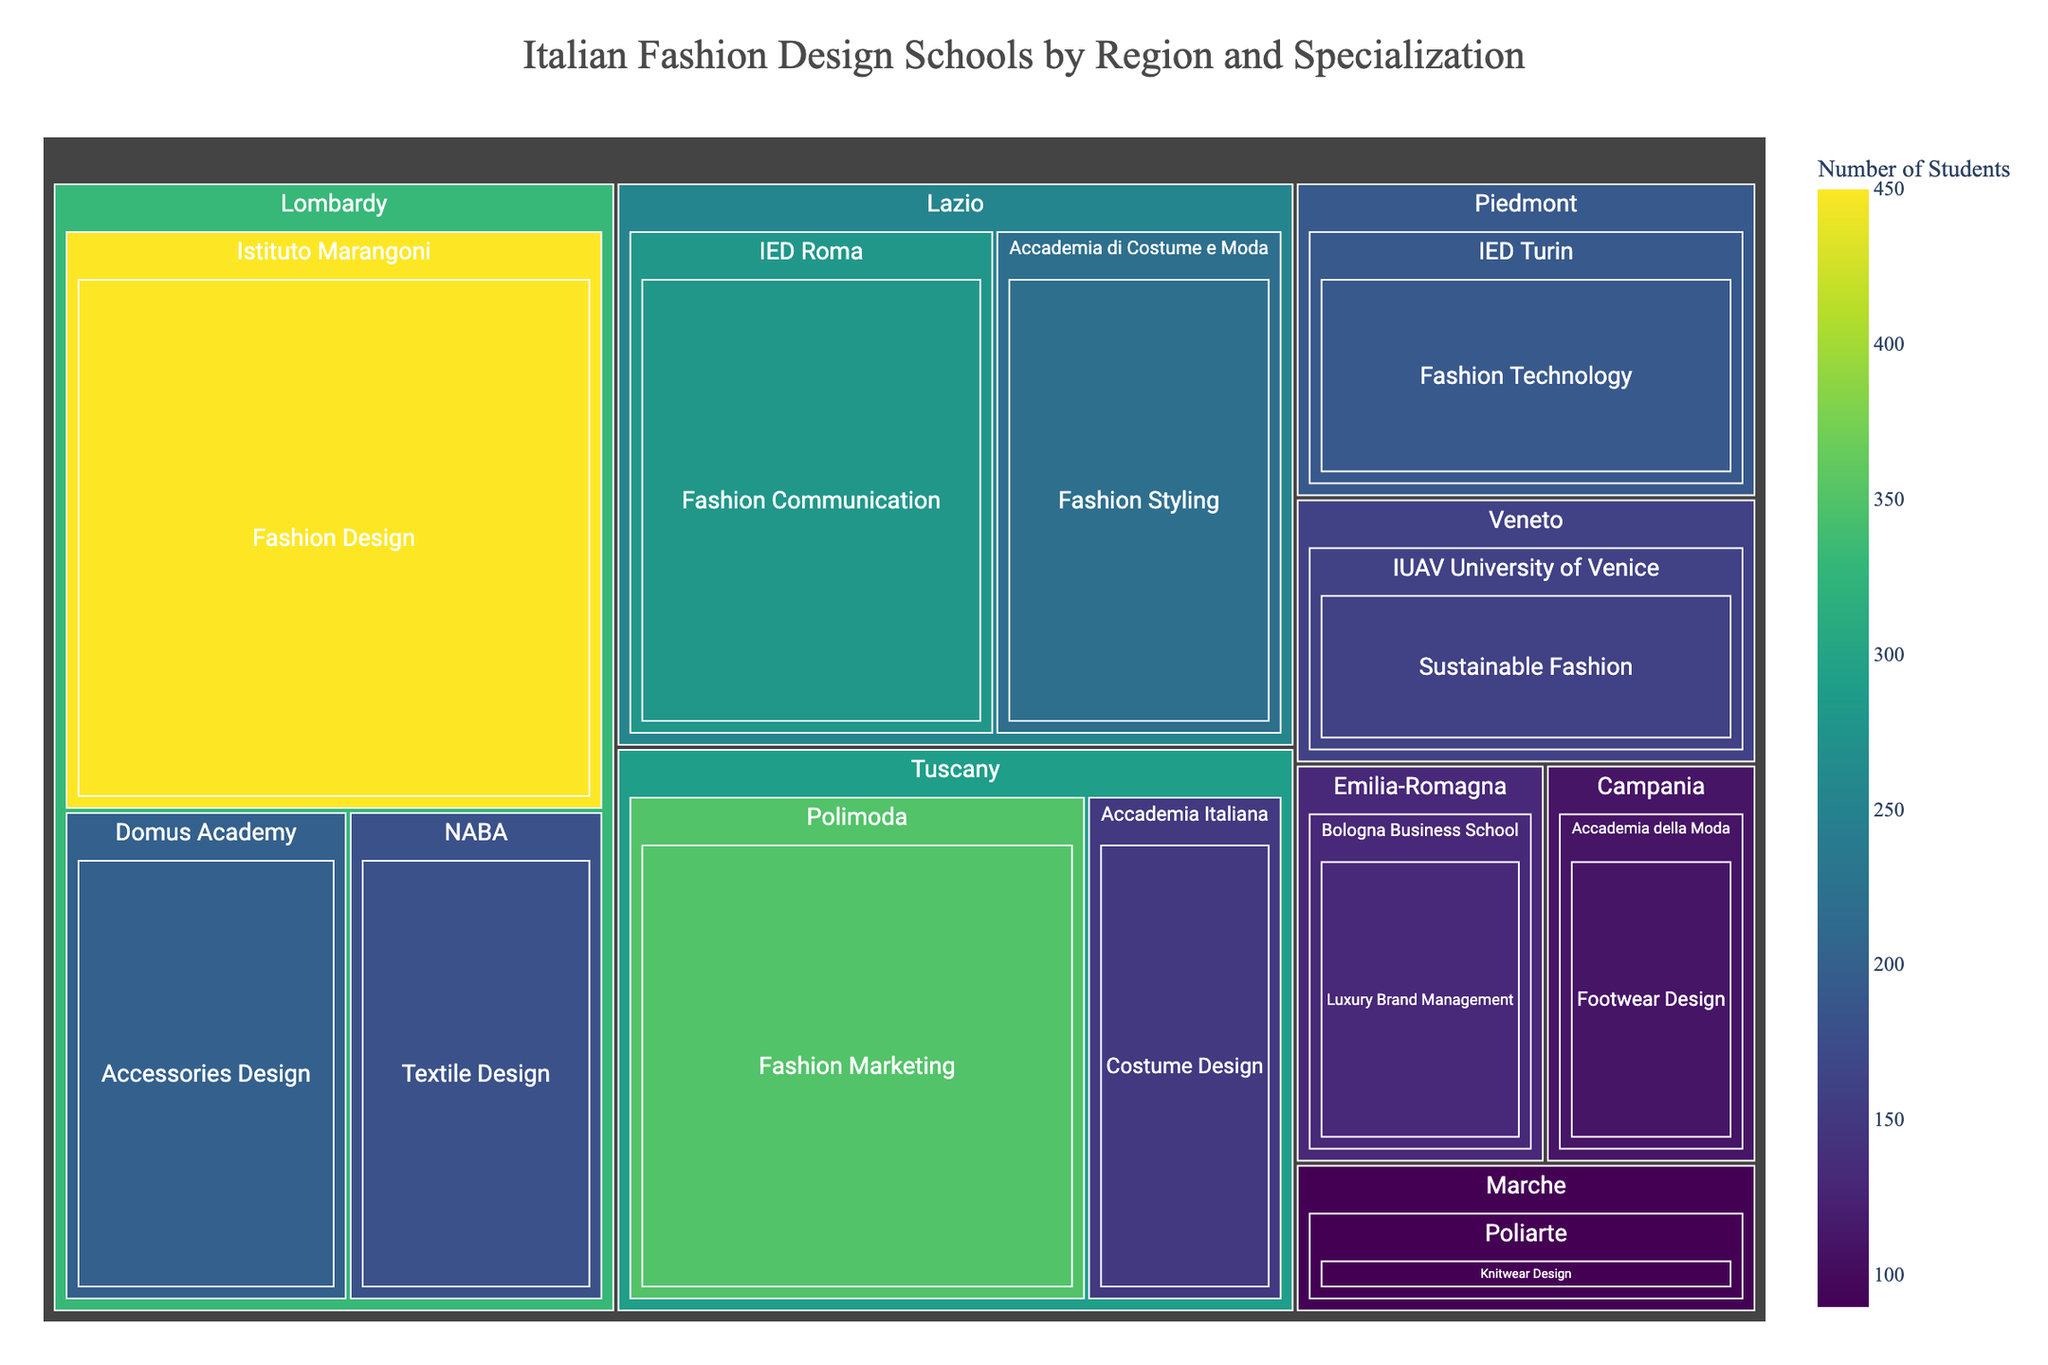What's the title of the figure? The title is at the top center of the figure and reads "Italian Fashion Design Schools by Region and Specialization".
Answer: Italian Fashion Design Schools by Region and Specialization Which region has the highest number of students in a single school? The region with the highest number of students in a single school can be identified by the largest tile within the treemap. The largest tile belongs to Istituto Marangoni in Lombardy with 450 students.
Answer: Lombardy How many schools are represented in the Lazio region? We count the number of tiles within the Lazio section of the treemap. There are two tiles: Accademia di Costume e Moda and IED Roma.
Answer: 2 What is the combined number of students for the schools in Tuscany? Add the number of students from the schools in Tuscany: Polimoda (350) and Accademia Italiana (150). The sum is 350 + 150.
Answer: 500 Which specialization has the highest number of students in Emilia-Romagna? Examine the Emilia-Romagna section and identify the specialization within Bologna Business School. It is Luxury Brand Management with 130 students.
Answer: Luxury Brand Management How does the number of students in Fashion Design compare across the regions? Look at the "Fashion Design" specializations. The only Fashion Design school is Istituto Marangoni in Lombardy with 450 students. No other region has that specialization.
Answer: Lombardy has 450 students in Fashion Design, no other Fashion Design schools in other regions What's the difference in the number of students between the largest and smallest schools in the dataset? Identify the largest and smallest schools: Istituto Marangoni (450) and Poliarte (90). Calculate the difference: 450 - 90.
Answer: 360 Which region has the most diverse range of specializations? Assess which region has the most different specializations listed. Lombardy has Fashion Design, Accessories Design, and Textile Design, totaling three different specializations.
Answer: Lombardy What is the average number of students per school in Veneto? Identify and add the student numbers for Veneto's IUAV University of Venice (160), then divide by the number of schools (1): 160 / 1.
Answer: 160 